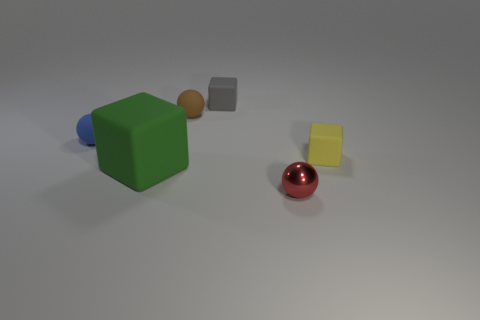There is a tiny ball that is in front of the tiny yellow rubber cube; is it the same color as the big cube?
Provide a succinct answer. No. How many cyan things are rubber cylinders or matte objects?
Provide a short and direct response. 0. Are there any other things that have the same material as the brown object?
Offer a very short reply. Yes. Does the object in front of the big green matte block have the same material as the tiny blue thing?
Provide a succinct answer. No. How many things are tiny red shiny cylinders or small objects that are behind the tiny yellow thing?
Give a very brief answer. 3. There is a small rubber cube in front of the small gray block that is behind the large green matte cube; what number of large green objects are in front of it?
Provide a short and direct response. 1. There is a tiny rubber object to the right of the red thing; does it have the same shape as the gray object?
Give a very brief answer. Yes. There is a block that is to the left of the tiny gray matte cube; is there a small yellow rubber object that is on the left side of it?
Your answer should be very brief. No. What number of tiny red balls are there?
Give a very brief answer. 1. There is a cube that is on the right side of the brown rubber ball and in front of the small blue ball; what color is it?
Provide a succinct answer. Yellow. 